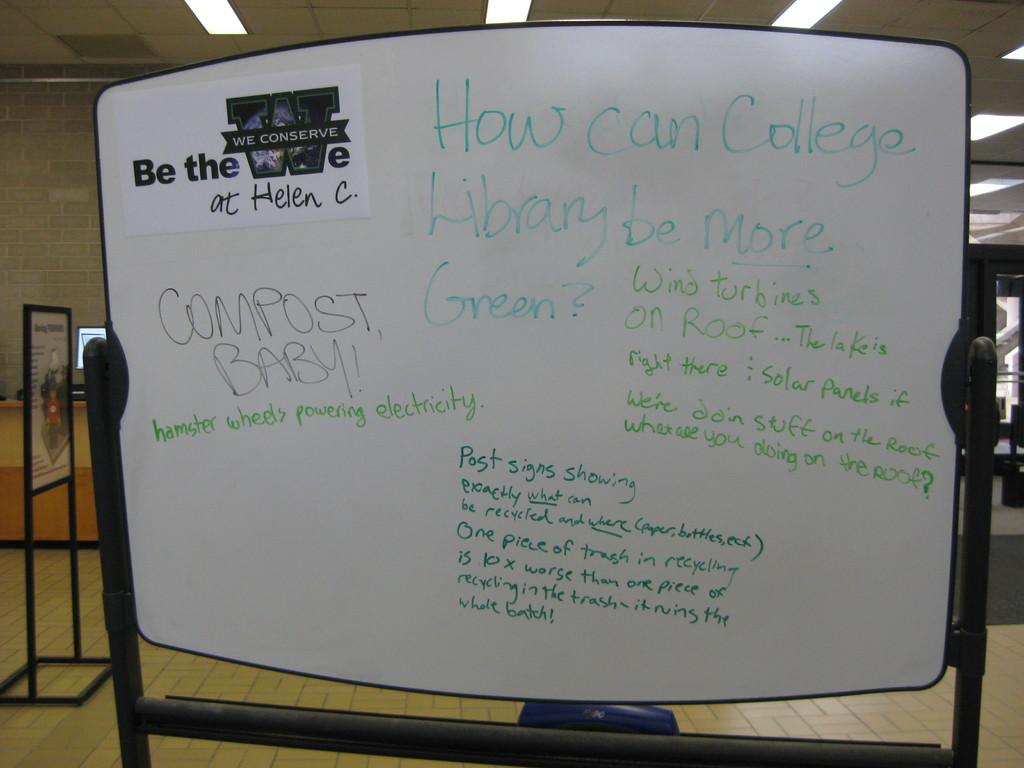<image>
Provide a brief description of the given image. a white board with words How can college library be more green 